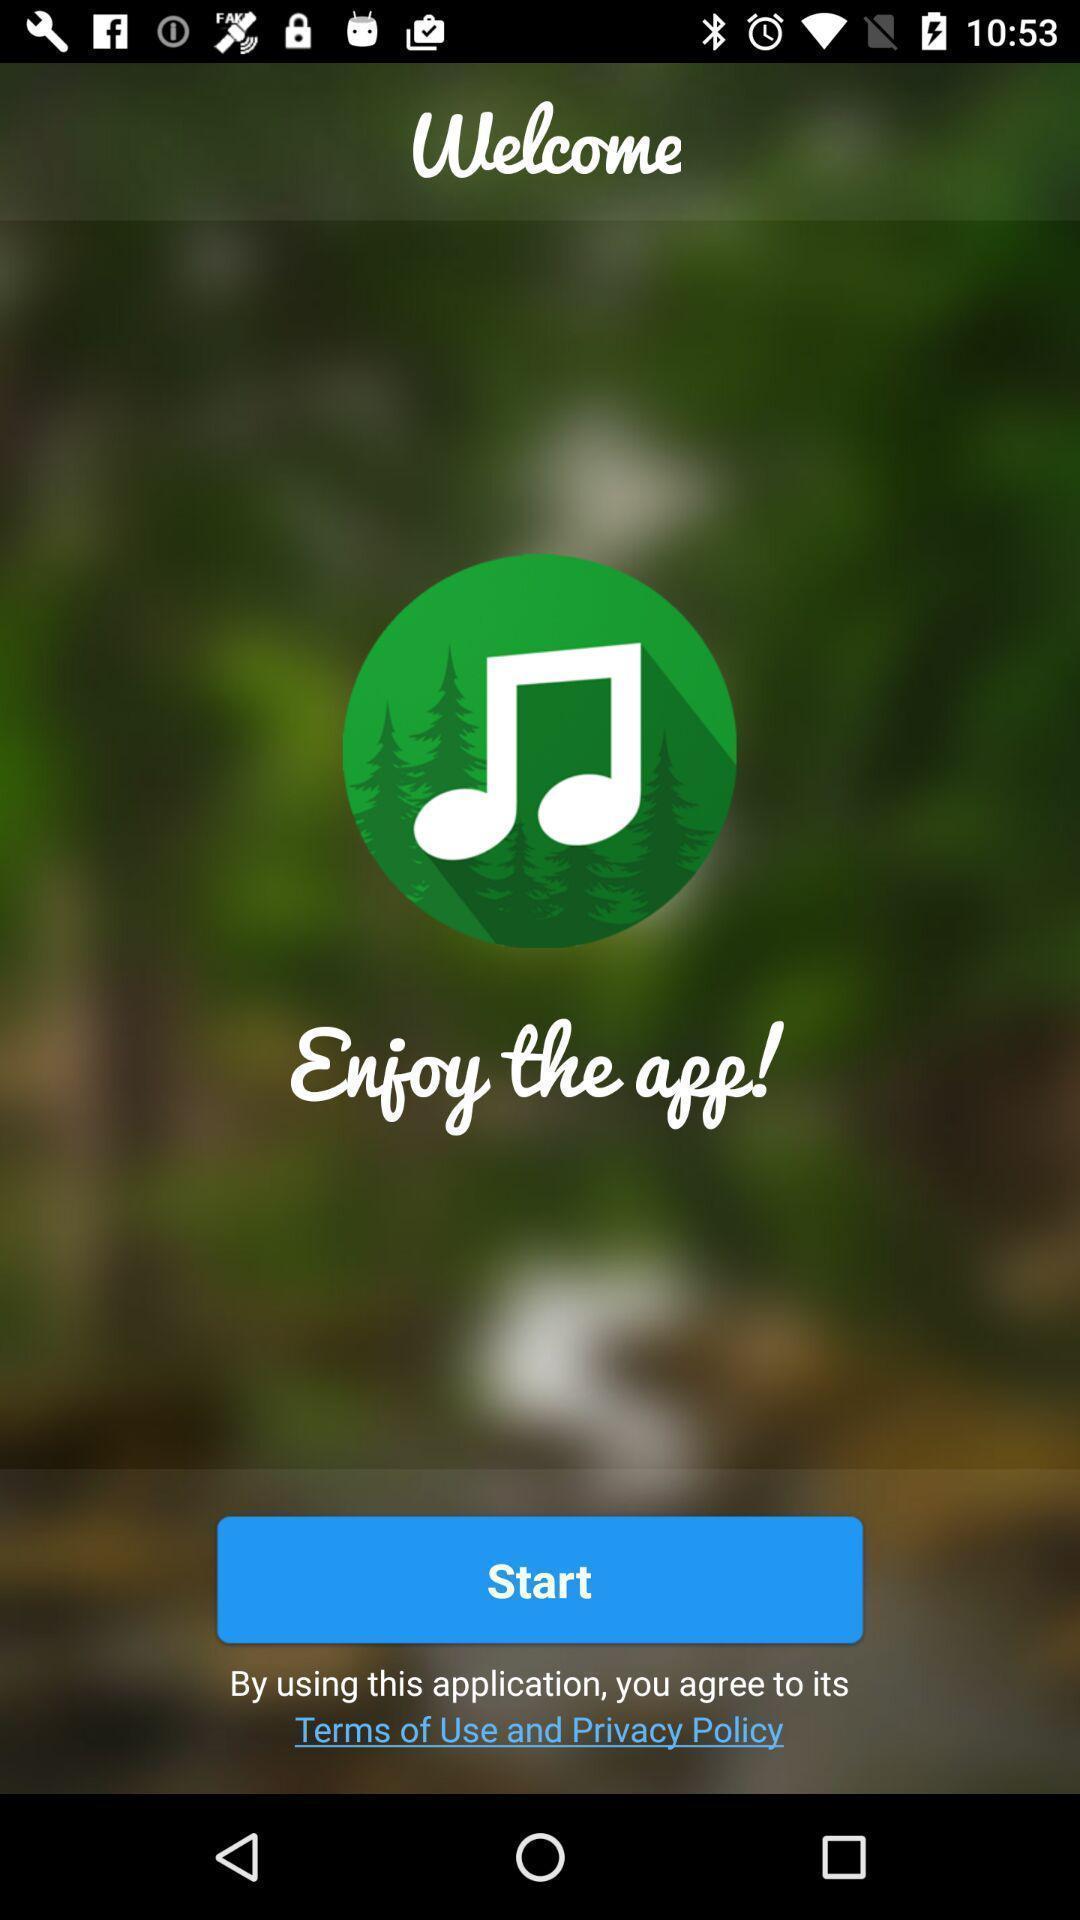Explain what's happening in this screen capture. Welcome page. 